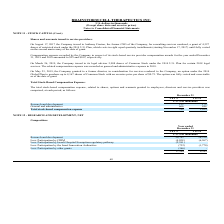According to Brainstorm Cell Therapeutics's financial document, What is the compensation expense recorded by the Company for the year ended December 31, 2019? According to the financial document, $25. The relevant text states: "year ended December 31, 2019 and 2018 amounted to $25 and $102, respectively. On March 26, 2019, the Company issued to its legal advisor 5,908 shares of C..." Also, How many shares of the Common Stock were issued to the legal advisor on March 26, 2019? 5,908 shares of Common Stock. The document states: "26, 2019, the Company issued to its legal advisor 5,908 shares of Common Stock under the 2014 U.S. Plan for certain 2018 legal services. The related c..." Also, What is the exercise price per share under the 2014 Global Plan? According to the financial document, $0.75. The relevant text states: "f Common Stock with an exercise price per share of $0.75. The option was fully vested and exercisable as of the date of grant. Total Stock-Based Compensatio..." Also, can you calculate: What is the change in the research and development stock-based compensation expense from 2018 to 2019? Based on the calculation: 123-175, the result is -52 (in thousands). This is based on the information: "Research and development 123 175 Research and development 123 175..." The key data points involved are: 123, 175. Also, can you calculate: What is the change in the general and administrative stock-based compensation expense from 2018 to 2019? Based on the calculation: 666-844, the result is -178 (in thousands). This is based on the information: "General and administrative 666 844 General and administrative 666 844..." The key data points involved are: 666, 844. Also, can you calculate: What is the percentage change in the total stock-based compensation expense from 2018 to 2019? To answer this question, I need to perform calculations using the financial data. The calculation is: (789-1,019)/1,019, which equals -22.57 (percentage). This is based on the information: "Total stock-based compensation expense 789 1,019 Total stock-based compensation expense 789 1,019..." The key data points involved are: 1,019, 789. 